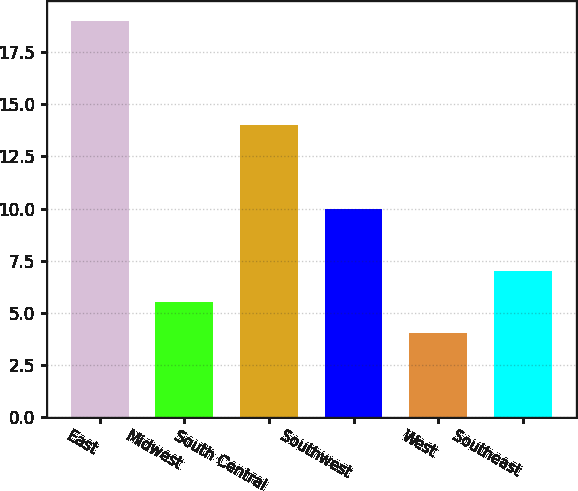<chart> <loc_0><loc_0><loc_500><loc_500><bar_chart><fcel>East<fcel>Midwest<fcel>South Central<fcel>Southwest<fcel>West<fcel>Southeast<nl><fcel>19<fcel>5.5<fcel>14<fcel>10<fcel>4<fcel>7<nl></chart> 